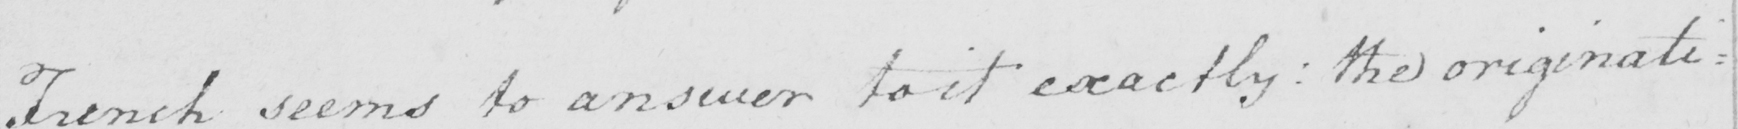Can you read and transcribe this handwriting? French seems to answer to it exactly :  the originati= 